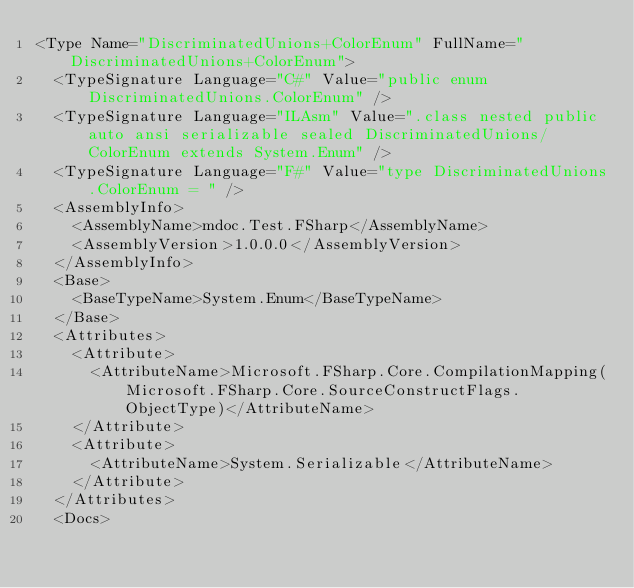<code> <loc_0><loc_0><loc_500><loc_500><_XML_><Type Name="DiscriminatedUnions+ColorEnum" FullName="DiscriminatedUnions+ColorEnum">
  <TypeSignature Language="C#" Value="public enum DiscriminatedUnions.ColorEnum" />
  <TypeSignature Language="ILAsm" Value=".class nested public auto ansi serializable sealed DiscriminatedUnions/ColorEnum extends System.Enum" />
  <TypeSignature Language="F#" Value="type DiscriminatedUnions.ColorEnum = " />
  <AssemblyInfo>
    <AssemblyName>mdoc.Test.FSharp</AssemblyName>
    <AssemblyVersion>1.0.0.0</AssemblyVersion>
  </AssemblyInfo>
  <Base>
    <BaseTypeName>System.Enum</BaseTypeName>
  </Base>
  <Attributes>
    <Attribute>
      <AttributeName>Microsoft.FSharp.Core.CompilationMapping(Microsoft.FSharp.Core.SourceConstructFlags.ObjectType)</AttributeName>
    </Attribute>
    <Attribute>
      <AttributeName>System.Serializable</AttributeName>
    </Attribute>
  </Attributes>
  <Docs></code> 